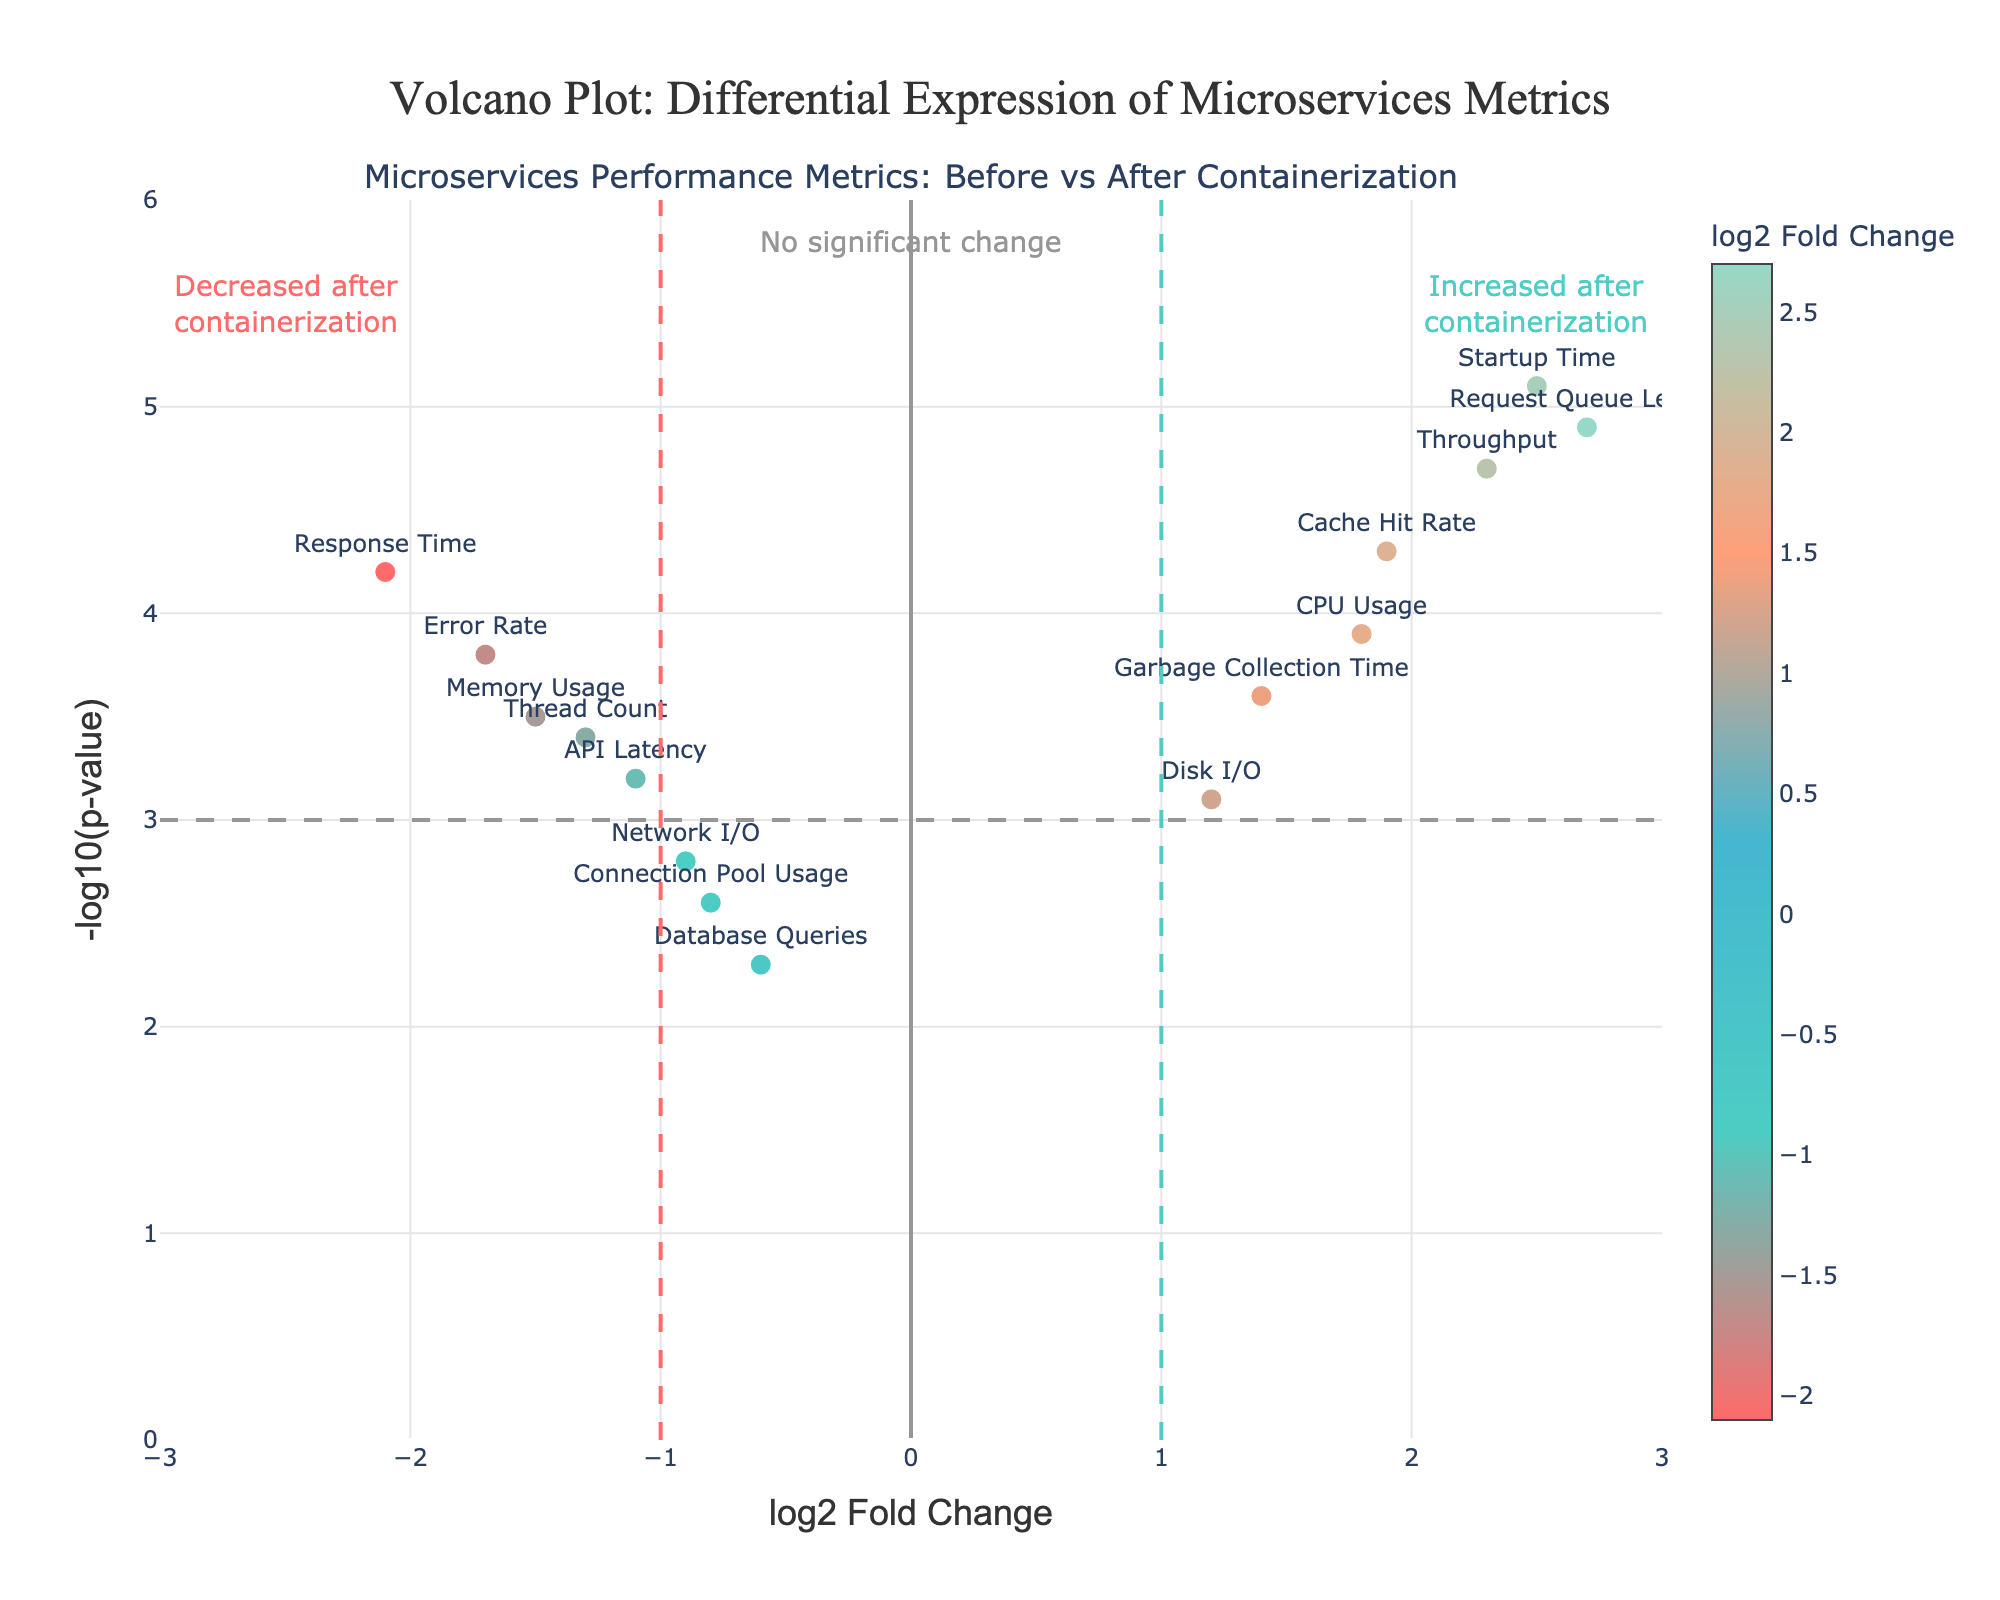What is the title of the plot? The plot's title is written at the top and is larger and bolder than other text elements.
Answer: "Volcano Plot: Differential Expression of Microservices Metrics" Which metric has the highest increase after containerization? To find the metric with the highest increase, look for the data point with the highest log2 Fold Change on the x-axis.
Answer: Request Queue Length Which metrics show a significant decrease after containerization? Significant decreases are indicated by points to the left of the bold vertical red line (-1) with high y-values (above the horizontal dashed line at 3). Identify these points.
Answer: Response Time, Memory Usage, Error Rate Which metric has the highest p-value? The p-value is inversely related to the y-axis value (negLog10PValue). The metric with the smallest y value has the highest p-value.
Answer: Database Queries How many metrics have a log2 Fold Change greater than 1 and a negLog10PValue greater than 3? Count the data points located to the right of the vertical green line (log2 Fold Change > 1) and above the horizontal dashed line (negLog10PValue > 3).
Answer: 5 For the metric 'Throughput', what are the log2 Fold Change and negLog10PValue values? Find 'Throughput' in the plot, then read its x and y coordinates.
Answer: log2 Fold Change: 2.3, negLog10PValue: 4.7 Which microservice metric has minimal change after containerization? The minimal change is shown by the metric closest to the central vertical axis (log2 Fold Change around 0).
Answer: Connection Pool Usage Of the metrics that increased after containerization, which has the lowest p-value? Examine the data points to the right of the central axis (positive log2 Fold Change) and identify the one with the highest y-axis value (lowest p-value).
Answer: Startup Time How does 'Disk I/O' perform after containerization compared to 'Memory Usage'? Compare their log2 Fold Change values: 'Disk I/O' (positive value, right side) vs. 'Memory Usage' (negative value, left side).
Answer: Disk I/O shows an increase, Memory Usage shows a decrease 